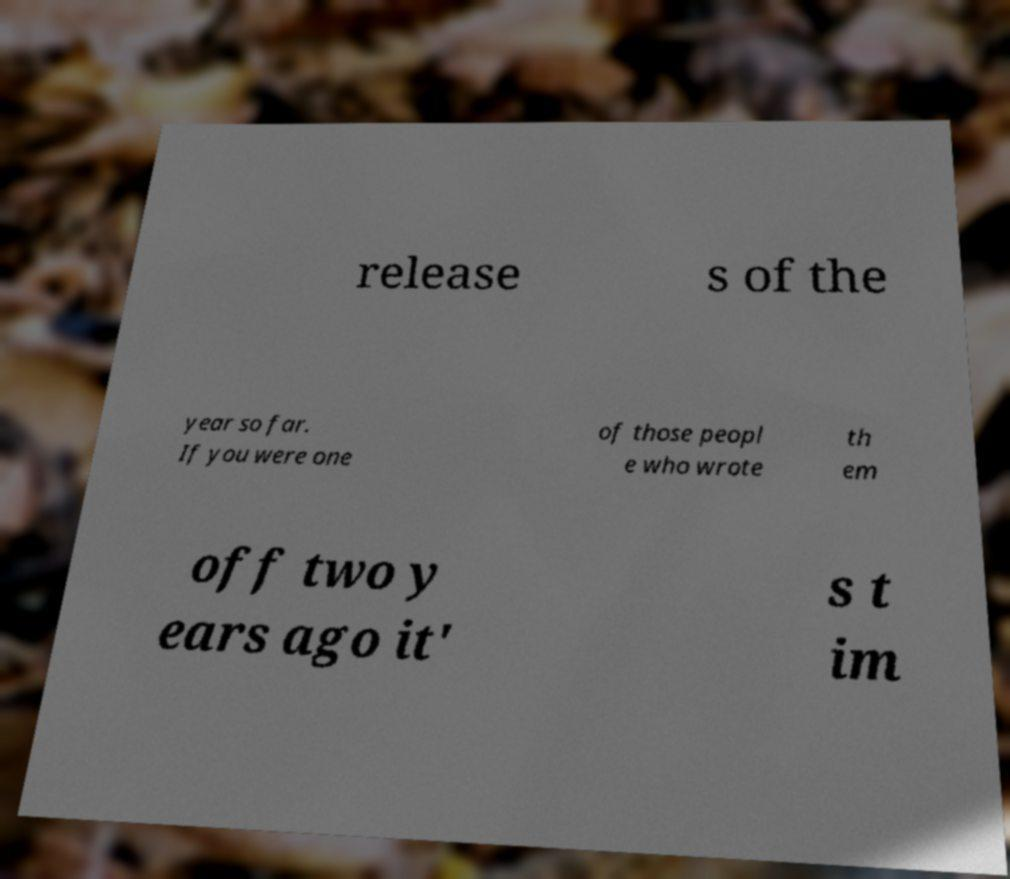Could you assist in decoding the text presented in this image and type it out clearly? release s of the year so far. If you were one of those peopl e who wrote th em off two y ears ago it' s t im 